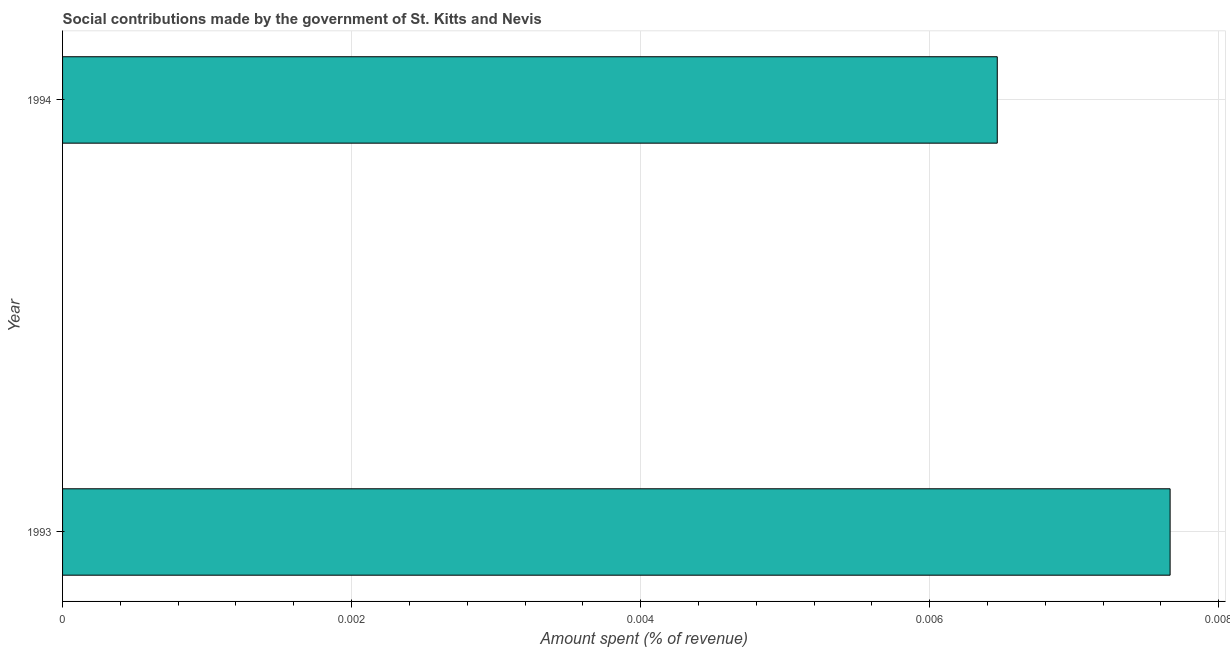Does the graph contain any zero values?
Provide a short and direct response. No. What is the title of the graph?
Offer a very short reply. Social contributions made by the government of St. Kitts and Nevis. What is the label or title of the X-axis?
Provide a short and direct response. Amount spent (% of revenue). What is the amount spent in making social contributions in 1993?
Provide a short and direct response. 0.01. Across all years, what is the maximum amount spent in making social contributions?
Keep it short and to the point. 0.01. Across all years, what is the minimum amount spent in making social contributions?
Your response must be concise. 0.01. What is the sum of the amount spent in making social contributions?
Give a very brief answer. 0.01. What is the average amount spent in making social contributions per year?
Provide a short and direct response. 0.01. What is the median amount spent in making social contributions?
Your answer should be compact. 0.01. What is the ratio of the amount spent in making social contributions in 1993 to that in 1994?
Your answer should be compact. 1.19. What is the difference between two consecutive major ticks on the X-axis?
Your response must be concise. 0. Are the values on the major ticks of X-axis written in scientific E-notation?
Give a very brief answer. No. What is the Amount spent (% of revenue) in 1993?
Ensure brevity in your answer.  0.01. What is the Amount spent (% of revenue) in 1994?
Offer a very short reply. 0.01. What is the difference between the Amount spent (% of revenue) in 1993 and 1994?
Your answer should be compact. 0. What is the ratio of the Amount spent (% of revenue) in 1993 to that in 1994?
Make the answer very short. 1.19. 